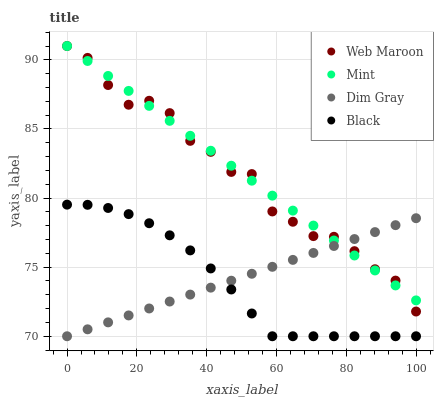Does Black have the minimum area under the curve?
Answer yes or no. Yes. Does Mint have the maximum area under the curve?
Answer yes or no. Yes. Does Dim Gray have the minimum area under the curve?
Answer yes or no. No. Does Dim Gray have the maximum area under the curve?
Answer yes or no. No. Is Dim Gray the smoothest?
Answer yes or no. Yes. Is Web Maroon the roughest?
Answer yes or no. Yes. Is Web Maroon the smoothest?
Answer yes or no. No. Is Dim Gray the roughest?
Answer yes or no. No. Does Dim Gray have the lowest value?
Answer yes or no. Yes. Does Web Maroon have the lowest value?
Answer yes or no. No. Does Web Maroon have the highest value?
Answer yes or no. Yes. Does Dim Gray have the highest value?
Answer yes or no. No. Is Black less than Web Maroon?
Answer yes or no. Yes. Is Mint greater than Black?
Answer yes or no. Yes. Does Dim Gray intersect Black?
Answer yes or no. Yes. Is Dim Gray less than Black?
Answer yes or no. No. Is Dim Gray greater than Black?
Answer yes or no. No. Does Black intersect Web Maroon?
Answer yes or no. No. 